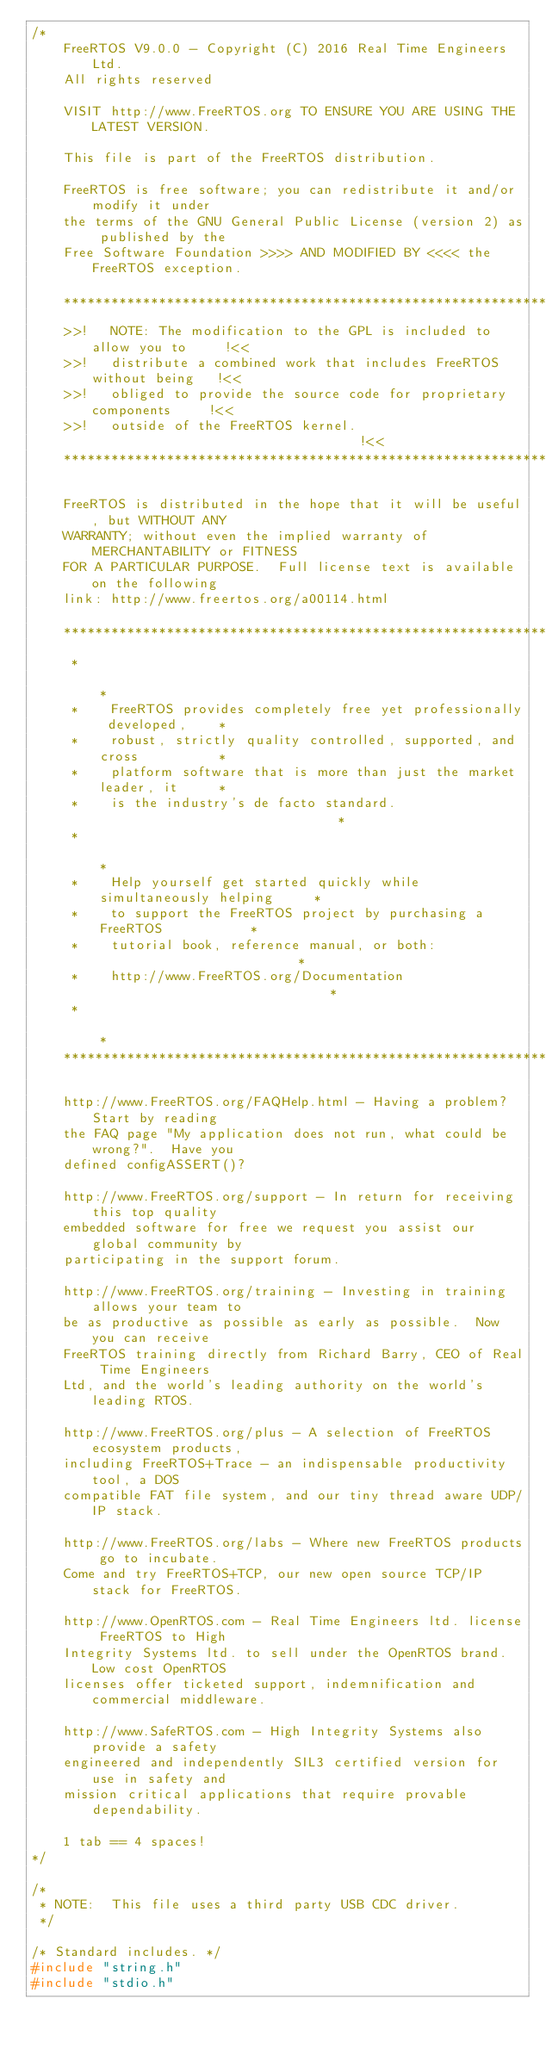<code> <loc_0><loc_0><loc_500><loc_500><_C_>/*
    FreeRTOS V9.0.0 - Copyright (C) 2016 Real Time Engineers Ltd.
    All rights reserved

    VISIT http://www.FreeRTOS.org TO ENSURE YOU ARE USING THE LATEST VERSION.

    This file is part of the FreeRTOS distribution.

    FreeRTOS is free software; you can redistribute it and/or modify it under
    the terms of the GNU General Public License (version 2) as published by the
    Free Software Foundation >>>> AND MODIFIED BY <<<< the FreeRTOS exception.

    ***************************************************************************
    >>!   NOTE: The modification to the GPL is included to allow you to     !<<
    >>!   distribute a combined work that includes FreeRTOS without being   !<<
    >>!   obliged to provide the source code for proprietary components     !<<
    >>!   outside of the FreeRTOS kernel.                                   !<<
    ***************************************************************************

    FreeRTOS is distributed in the hope that it will be useful, but WITHOUT ANY
    WARRANTY; without even the implied warranty of MERCHANTABILITY or FITNESS
    FOR A PARTICULAR PURPOSE.  Full license text is available on the following
    link: http://www.freertos.org/a00114.html

    ***************************************************************************
     *                                                                       *
     *    FreeRTOS provides completely free yet professionally developed,    *
     *    robust, strictly quality controlled, supported, and cross          *
     *    platform software that is more than just the market leader, it     *
     *    is the industry's de facto standard.                               *
     *                                                                       *
     *    Help yourself get started quickly while simultaneously helping     *
     *    to support the FreeRTOS project by purchasing a FreeRTOS           *
     *    tutorial book, reference manual, or both:                          *
     *    http://www.FreeRTOS.org/Documentation                              *
     *                                                                       *
    ***************************************************************************

    http://www.FreeRTOS.org/FAQHelp.html - Having a problem?  Start by reading
    the FAQ page "My application does not run, what could be wrong?".  Have you
    defined configASSERT()?

    http://www.FreeRTOS.org/support - In return for receiving this top quality
    embedded software for free we request you assist our global community by
    participating in the support forum.

    http://www.FreeRTOS.org/training - Investing in training allows your team to
    be as productive as possible as early as possible.  Now you can receive
    FreeRTOS training directly from Richard Barry, CEO of Real Time Engineers
    Ltd, and the world's leading authority on the world's leading RTOS.

    http://www.FreeRTOS.org/plus - A selection of FreeRTOS ecosystem products,
    including FreeRTOS+Trace - an indispensable productivity tool, a DOS
    compatible FAT file system, and our tiny thread aware UDP/IP stack.

    http://www.FreeRTOS.org/labs - Where new FreeRTOS products go to incubate.
    Come and try FreeRTOS+TCP, our new open source TCP/IP stack for FreeRTOS.

    http://www.OpenRTOS.com - Real Time Engineers ltd. license FreeRTOS to High
    Integrity Systems ltd. to sell under the OpenRTOS brand.  Low cost OpenRTOS
    licenses offer ticketed support, indemnification and commercial middleware.

    http://www.SafeRTOS.com - High Integrity Systems also provide a safety
    engineered and independently SIL3 certified version for use in safety and
    mission critical applications that require provable dependability.

    1 tab == 4 spaces!
*/

/*
 * NOTE:  This file uses a third party USB CDC driver.
 */

/* Standard includes. */
#include "string.h"
#include "stdio.h"
</code> 